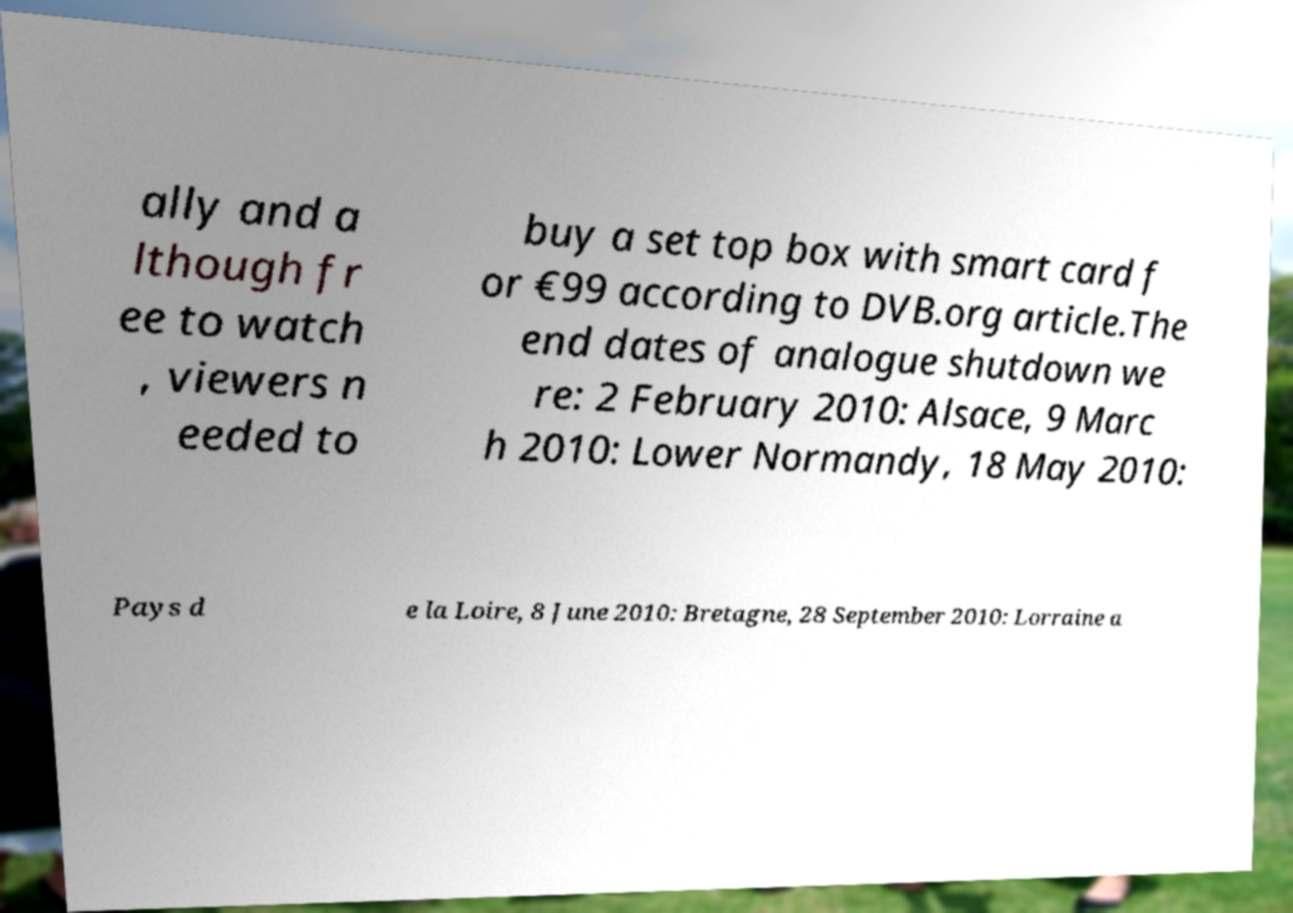Could you assist in decoding the text presented in this image and type it out clearly? ally and a lthough fr ee to watch , viewers n eeded to buy a set top box with smart card f or €99 according to DVB.org article.The end dates of analogue shutdown we re: 2 February 2010: Alsace, 9 Marc h 2010: Lower Normandy, 18 May 2010: Pays d e la Loire, 8 June 2010: Bretagne, 28 September 2010: Lorraine a 